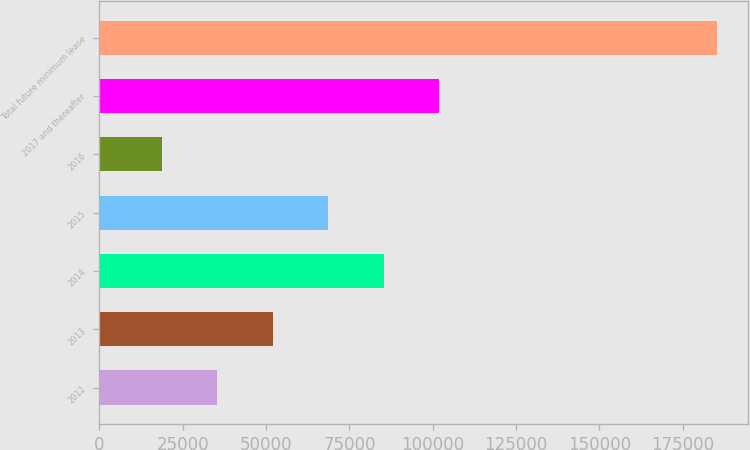Convert chart to OTSL. <chart><loc_0><loc_0><loc_500><loc_500><bar_chart><fcel>2012<fcel>2013<fcel>2014<fcel>2015<fcel>2016<fcel>2017 and thereafter<fcel>Total future minimum lease<nl><fcel>35378.4<fcel>52022.8<fcel>85311.6<fcel>68667.2<fcel>18734<fcel>101956<fcel>185178<nl></chart> 